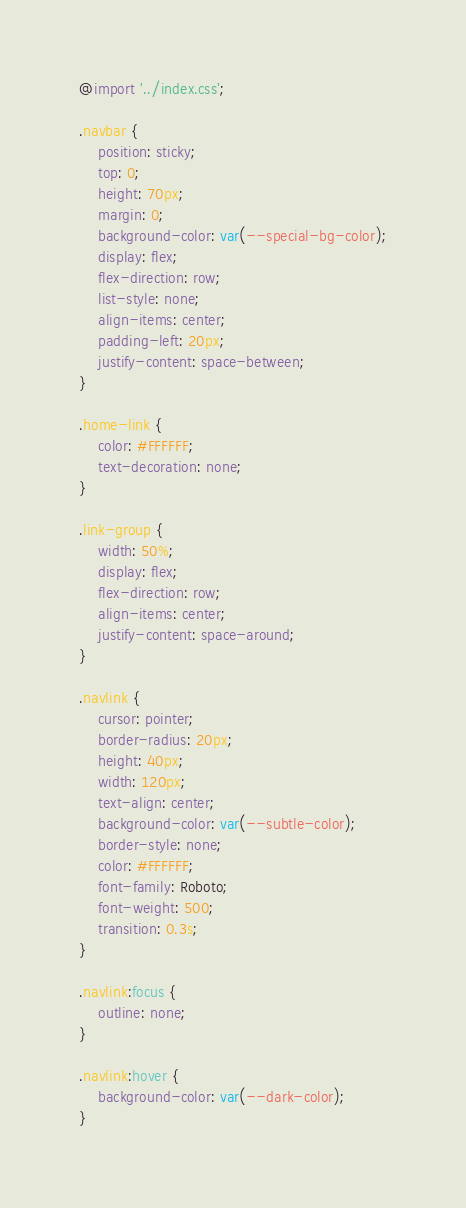Convert code to text. <code><loc_0><loc_0><loc_500><loc_500><_CSS_>@import '../index.css';

.navbar {
	position: sticky;
	top: 0;
	height: 70px;
	margin: 0;
	background-color: var(--special-bg-color);
	display: flex;
	flex-direction: row;
	list-style: none;
	align-items: center;
	padding-left: 20px;
	justify-content: space-between;
}

.home-link {
	color: #FFFFFF;
	text-decoration: none;
}

.link-group {
	width: 50%;
	display: flex;
	flex-direction: row;
	align-items: center;
	justify-content: space-around;
}

.navlink {
	cursor: pointer;
	border-radius: 20px;
	height: 40px;
	width: 120px;
	text-align: center;
	background-color: var(--subtle-color);
	border-style: none;
	color: #FFFFFF;
	font-family: Roboto;
	font-weight: 500;
	transition: 0.3s;
}

.navlink:focus {
	outline: none;
}

.navlink:hover {
	background-color: var(--dark-color);
}
</code> 